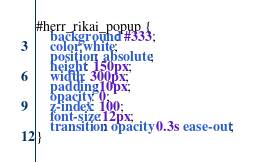<code> <loc_0><loc_0><loc_500><loc_500><_CSS_>#herr_rikai_popup { 
	background: #333; 
	color:white; 
	position: absolute; 
	height: 150px; 
	width: 300px; 
	padding:10px; 
	opacity: 0; 
	z-index: 100; 
	font-size:12px; 
	transition: opacity 0.3s ease-out; 
}</code> 